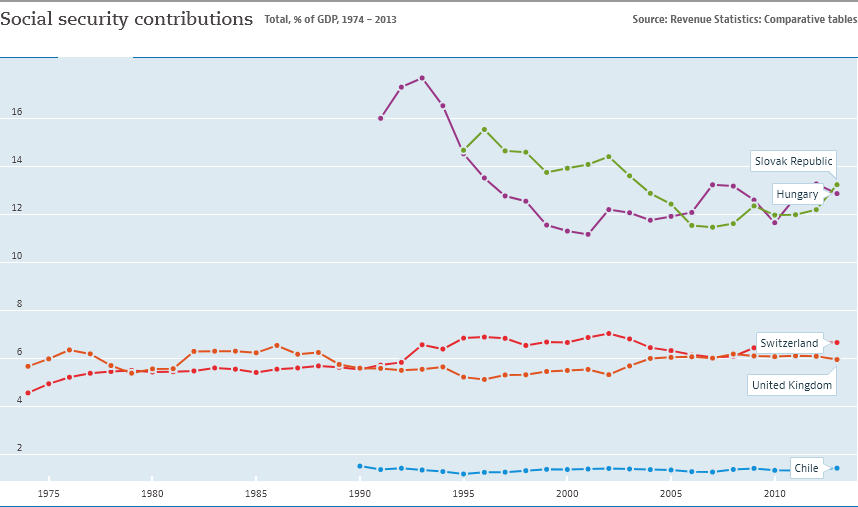Indicate a few pertinent items in this graphic. The country represented by the blue color line is Chile. 